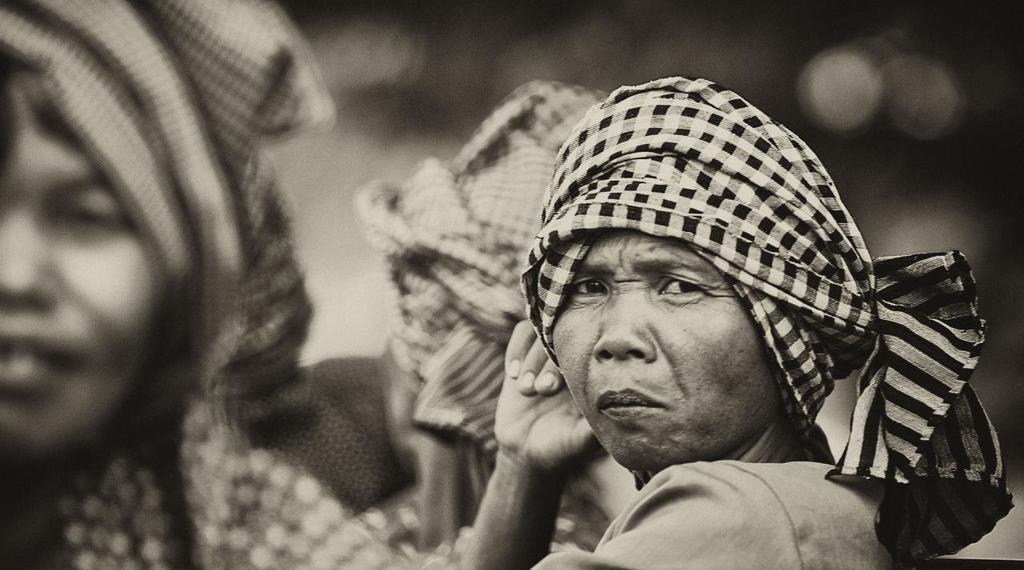Can you describe this image briefly? This is a black and white image. In this image, on the right side, we can see a person. On the left side, we can see another person. In the background, we can see a group of people and black color. 